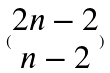<formula> <loc_0><loc_0><loc_500><loc_500>( \begin{matrix} 2 n - 2 \\ n - 2 \end{matrix} )</formula> 